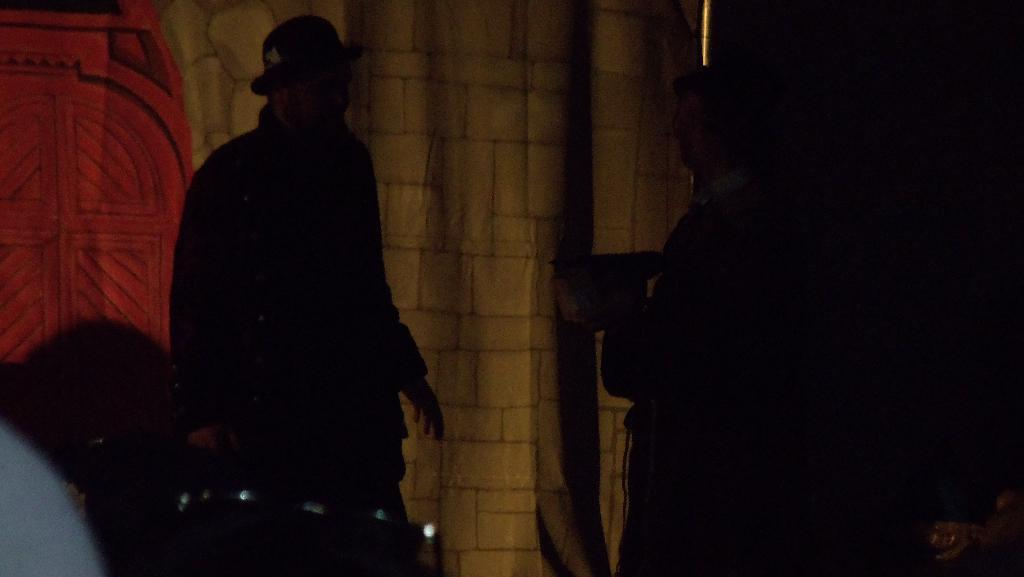What is happening in the image? There are people standing in the image. Can you describe the lighting in the image? The image appears to be dark. What can be seen in the background of the image? There is a stone wall and a red-colored door in the background of the image. What type of food is being prepared in the image? There is no food preparation visible in the image; it primarily features people standing and a stone wall with a red door in the background. 